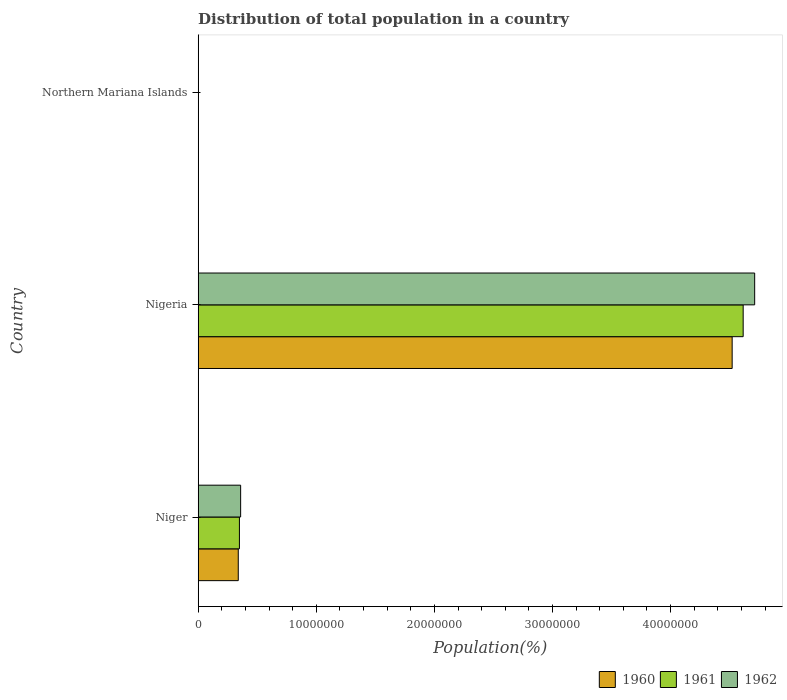Are the number of bars per tick equal to the number of legend labels?
Offer a very short reply. Yes. Are the number of bars on each tick of the Y-axis equal?
Ensure brevity in your answer.  Yes. What is the label of the 2nd group of bars from the top?
Give a very brief answer. Nigeria. What is the population of in 1961 in Northern Mariana Islands?
Provide a short and direct response. 1.03e+04. Across all countries, what is the maximum population of in 1960?
Your answer should be compact. 4.52e+07. Across all countries, what is the minimum population of in 1961?
Your response must be concise. 1.03e+04. In which country was the population of in 1961 maximum?
Offer a terse response. Nigeria. In which country was the population of in 1960 minimum?
Your answer should be compact. Northern Mariana Islands. What is the total population of in 1962 in the graph?
Ensure brevity in your answer.  5.07e+07. What is the difference between the population of in 1960 in Niger and that in Nigeria?
Make the answer very short. -4.18e+07. What is the difference between the population of in 1960 in Northern Mariana Islands and the population of in 1962 in Nigeria?
Provide a succinct answer. -4.71e+07. What is the average population of in 1961 per country?
Your answer should be compact. 1.65e+07. What is the difference between the population of in 1962 and population of in 1960 in Nigeria?
Provide a short and direct response. 1.91e+06. In how many countries, is the population of in 1962 greater than 14000000 %?
Provide a succinct answer. 1. What is the ratio of the population of in 1960 in Nigeria to that in Northern Mariana Islands?
Your answer should be compact. 4489.73. Is the population of in 1962 in Nigeria less than that in Northern Mariana Islands?
Provide a succinct answer. No. What is the difference between the highest and the second highest population of in 1961?
Give a very brief answer. 4.27e+07. What is the difference between the highest and the lowest population of in 1960?
Make the answer very short. 4.52e+07. What does the 1st bar from the top in Northern Mariana Islands represents?
Provide a short and direct response. 1962. What does the 1st bar from the bottom in Niger represents?
Keep it short and to the point. 1960. Is it the case that in every country, the sum of the population of in 1961 and population of in 1960 is greater than the population of in 1962?
Provide a succinct answer. Yes. How many bars are there?
Give a very brief answer. 9. How many countries are there in the graph?
Your response must be concise. 3. What is the difference between two consecutive major ticks on the X-axis?
Your response must be concise. 1.00e+07. Are the values on the major ticks of X-axis written in scientific E-notation?
Provide a succinct answer. No. Does the graph contain any zero values?
Your response must be concise. No. How are the legend labels stacked?
Provide a short and direct response. Horizontal. What is the title of the graph?
Offer a terse response. Distribution of total population in a country. What is the label or title of the X-axis?
Provide a succinct answer. Population(%). What is the Population(%) of 1960 in Niger?
Your response must be concise. 3.40e+06. What is the Population(%) in 1961 in Niger?
Keep it short and to the point. 3.49e+06. What is the Population(%) of 1962 in Niger?
Offer a very short reply. 3.60e+06. What is the Population(%) of 1960 in Nigeria?
Ensure brevity in your answer.  4.52e+07. What is the Population(%) of 1961 in Nigeria?
Ensure brevity in your answer.  4.61e+07. What is the Population(%) in 1962 in Nigeria?
Make the answer very short. 4.71e+07. What is the Population(%) of 1960 in Northern Mariana Islands?
Offer a terse response. 1.01e+04. What is the Population(%) in 1961 in Northern Mariana Islands?
Ensure brevity in your answer.  1.03e+04. What is the Population(%) in 1962 in Northern Mariana Islands?
Ensure brevity in your answer.  1.05e+04. Across all countries, what is the maximum Population(%) in 1960?
Keep it short and to the point. 4.52e+07. Across all countries, what is the maximum Population(%) of 1961?
Provide a succinct answer. 4.61e+07. Across all countries, what is the maximum Population(%) of 1962?
Your response must be concise. 4.71e+07. Across all countries, what is the minimum Population(%) in 1960?
Your response must be concise. 1.01e+04. Across all countries, what is the minimum Population(%) in 1961?
Provide a short and direct response. 1.03e+04. Across all countries, what is the minimum Population(%) in 1962?
Your answer should be very brief. 1.05e+04. What is the total Population(%) of 1960 in the graph?
Make the answer very short. 4.86e+07. What is the total Population(%) of 1961 in the graph?
Your answer should be very brief. 4.96e+07. What is the total Population(%) in 1962 in the graph?
Your answer should be compact. 5.07e+07. What is the difference between the Population(%) of 1960 in Niger and that in Nigeria?
Keep it short and to the point. -4.18e+07. What is the difference between the Population(%) of 1961 in Niger and that in Nigeria?
Your answer should be compact. -4.27e+07. What is the difference between the Population(%) of 1962 in Niger and that in Nigeria?
Offer a terse response. -4.35e+07. What is the difference between the Population(%) of 1960 in Niger and that in Northern Mariana Islands?
Your answer should be compact. 3.39e+06. What is the difference between the Population(%) of 1961 in Niger and that in Northern Mariana Islands?
Offer a terse response. 3.48e+06. What is the difference between the Population(%) in 1962 in Niger and that in Northern Mariana Islands?
Make the answer very short. 3.59e+06. What is the difference between the Population(%) in 1960 in Nigeria and that in Northern Mariana Islands?
Offer a very short reply. 4.52e+07. What is the difference between the Population(%) in 1961 in Nigeria and that in Northern Mariana Islands?
Provide a short and direct response. 4.61e+07. What is the difference between the Population(%) in 1962 in Nigeria and that in Northern Mariana Islands?
Provide a short and direct response. 4.71e+07. What is the difference between the Population(%) of 1960 in Niger and the Population(%) of 1961 in Nigeria?
Make the answer very short. -4.27e+07. What is the difference between the Population(%) of 1960 in Niger and the Population(%) of 1962 in Nigeria?
Your answer should be compact. -4.37e+07. What is the difference between the Population(%) in 1961 in Niger and the Population(%) in 1962 in Nigeria?
Your answer should be very brief. -4.36e+07. What is the difference between the Population(%) of 1960 in Niger and the Population(%) of 1961 in Northern Mariana Islands?
Provide a short and direct response. 3.38e+06. What is the difference between the Population(%) in 1960 in Niger and the Population(%) in 1962 in Northern Mariana Islands?
Your answer should be compact. 3.38e+06. What is the difference between the Population(%) in 1961 in Niger and the Population(%) in 1962 in Northern Mariana Islands?
Ensure brevity in your answer.  3.48e+06. What is the difference between the Population(%) of 1960 in Nigeria and the Population(%) of 1961 in Northern Mariana Islands?
Provide a short and direct response. 4.52e+07. What is the difference between the Population(%) of 1960 in Nigeria and the Population(%) of 1962 in Northern Mariana Islands?
Your answer should be very brief. 4.52e+07. What is the difference between the Population(%) of 1961 in Nigeria and the Population(%) of 1962 in Northern Mariana Islands?
Provide a short and direct response. 4.61e+07. What is the average Population(%) of 1960 per country?
Offer a very short reply. 1.62e+07. What is the average Population(%) of 1961 per country?
Your answer should be very brief. 1.65e+07. What is the average Population(%) of 1962 per country?
Provide a succinct answer. 1.69e+07. What is the difference between the Population(%) of 1960 and Population(%) of 1961 in Niger?
Keep it short and to the point. -9.84e+04. What is the difference between the Population(%) in 1960 and Population(%) in 1962 in Niger?
Offer a very short reply. -2.01e+05. What is the difference between the Population(%) of 1961 and Population(%) of 1962 in Niger?
Your answer should be very brief. -1.03e+05. What is the difference between the Population(%) in 1960 and Population(%) in 1961 in Nigeria?
Your answer should be compact. -9.33e+05. What is the difference between the Population(%) of 1960 and Population(%) of 1962 in Nigeria?
Ensure brevity in your answer.  -1.91e+06. What is the difference between the Population(%) of 1961 and Population(%) of 1962 in Nigeria?
Ensure brevity in your answer.  -9.74e+05. What is the difference between the Population(%) in 1960 and Population(%) in 1961 in Northern Mariana Islands?
Offer a very short reply. -270. What is the difference between the Population(%) of 1960 and Population(%) of 1962 in Northern Mariana Islands?
Offer a very short reply. -471. What is the difference between the Population(%) in 1961 and Population(%) in 1962 in Northern Mariana Islands?
Make the answer very short. -201. What is the ratio of the Population(%) of 1960 in Niger to that in Nigeria?
Ensure brevity in your answer.  0.08. What is the ratio of the Population(%) in 1961 in Niger to that in Nigeria?
Offer a very short reply. 0.08. What is the ratio of the Population(%) of 1962 in Niger to that in Nigeria?
Provide a short and direct response. 0.08. What is the ratio of the Population(%) of 1960 in Niger to that in Northern Mariana Islands?
Make the answer very short. 337.16. What is the ratio of the Population(%) in 1961 in Niger to that in Northern Mariana Islands?
Ensure brevity in your answer.  337.88. What is the ratio of the Population(%) in 1962 in Niger to that in Northern Mariana Islands?
Provide a short and direct response. 341.2. What is the ratio of the Population(%) of 1960 in Nigeria to that in Northern Mariana Islands?
Keep it short and to the point. 4489.73. What is the ratio of the Population(%) in 1961 in Nigeria to that in Northern Mariana Islands?
Ensure brevity in your answer.  4462.68. What is the ratio of the Population(%) of 1962 in Nigeria to that in Northern Mariana Islands?
Your answer should be very brief. 4469.96. What is the difference between the highest and the second highest Population(%) of 1960?
Ensure brevity in your answer.  4.18e+07. What is the difference between the highest and the second highest Population(%) of 1961?
Provide a succinct answer. 4.27e+07. What is the difference between the highest and the second highest Population(%) in 1962?
Offer a very short reply. 4.35e+07. What is the difference between the highest and the lowest Population(%) of 1960?
Offer a very short reply. 4.52e+07. What is the difference between the highest and the lowest Population(%) in 1961?
Ensure brevity in your answer.  4.61e+07. What is the difference between the highest and the lowest Population(%) of 1962?
Give a very brief answer. 4.71e+07. 